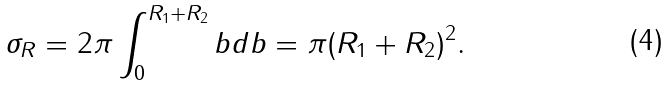Convert formula to latex. <formula><loc_0><loc_0><loc_500><loc_500>\sigma _ { R } = 2 \pi \int _ { 0 } ^ { R _ { 1 } + R _ { 2 } } b d b = \pi ( R _ { 1 } + R _ { 2 } ) ^ { 2 } .</formula> 